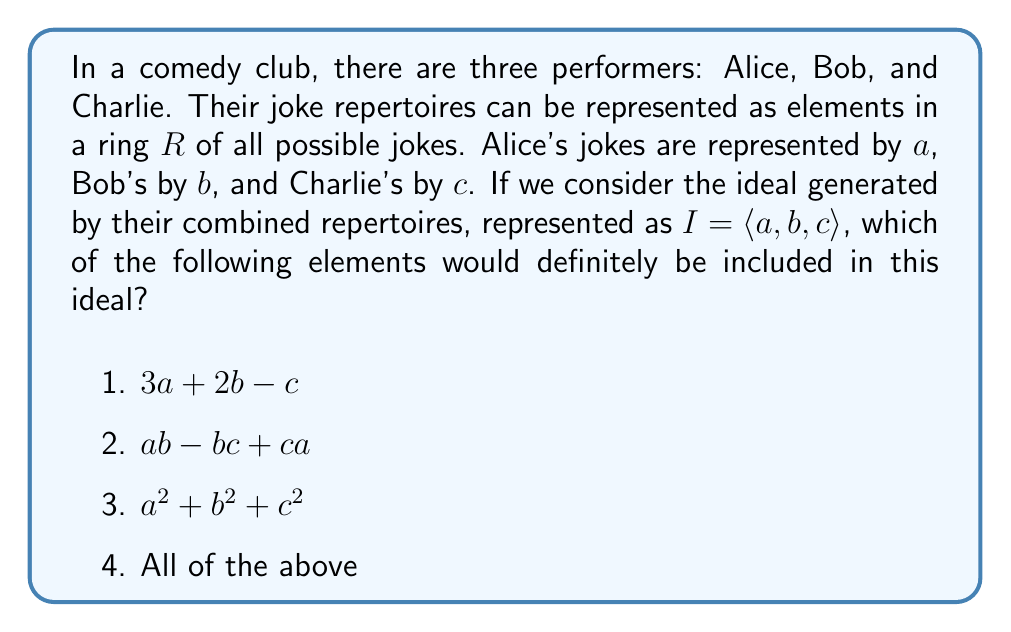Show me your answer to this math problem. Let's approach this step-by-step:

1) First, recall that an ideal $I$ in a ring $R$ is a subset of $R$ that is closed under addition and multiplication by any element of $R$.

2) The ideal generated by a set of elements $\{a_1, a_2, ..., a_n\}$ is the smallest ideal containing all these elements. It consists of all linear combinations of these elements and their products with any ring elements.

3) In our case, $I = \langle a, b, c \rangle$ is the ideal generated by $a$, $b$, and $c$. This means $I$ contains:
   
   a) All linear combinations of $a$, $b$, and $c$: $r_1a + r_2b + r_3c$, where $r_1, r_2, r_3 \in R$
   
   b) All products of these linear combinations with any element of $R$

4) Now, let's examine each option:

   1) $3a + 2b - c$ is a linear combination of $a$, $b$, and $c$, so it's in $I$.
   
   2) $ab - bc + ca$ is a sum of products of the generators, so it's in $I$.
   
   3) $a^2 + b^2 + c^2$ is a sum of products of the generators with themselves, so it's in $I$.

5) Therefore, all of the given elements are definitely included in the ideal $I$.

This concept can be likened to a storytelling workshop where jokes from different comedians (our generators) are combined and reworked (our ring operations) to create new material (elements of the ideal).
Answer: 4) All of the above 